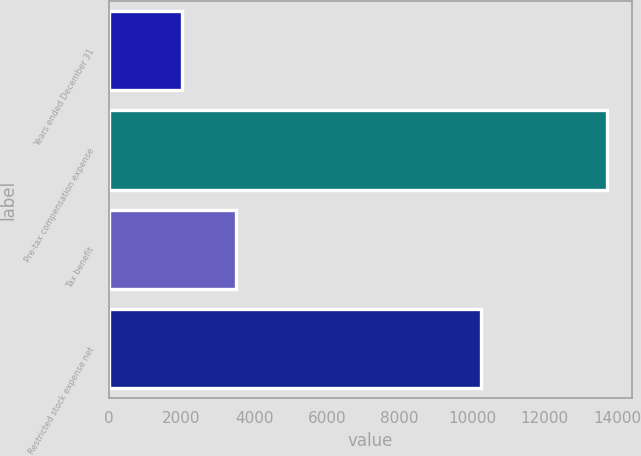<chart> <loc_0><loc_0><loc_500><loc_500><bar_chart><fcel>Years ended December 31<fcel>Pre-tax compensation expense<fcel>Tax benefit<fcel>Restricted stock expense net<nl><fcel>2018<fcel>13726<fcel>3486<fcel>10240<nl></chart> 